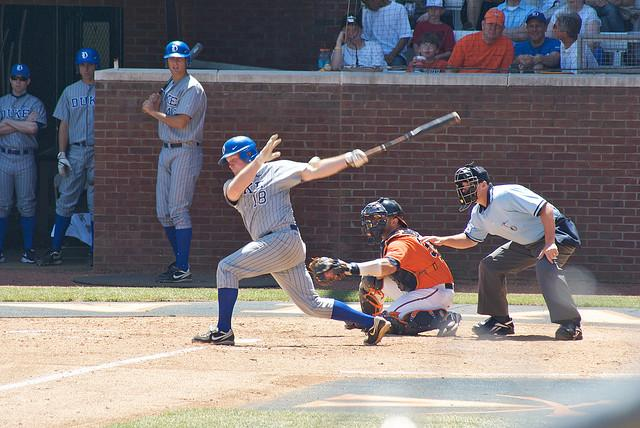What baseball player has the same first name as the name on the player all the way to the left's jersey? Please explain your reasoning. duke snider. Duke snider has the name "duke.". 